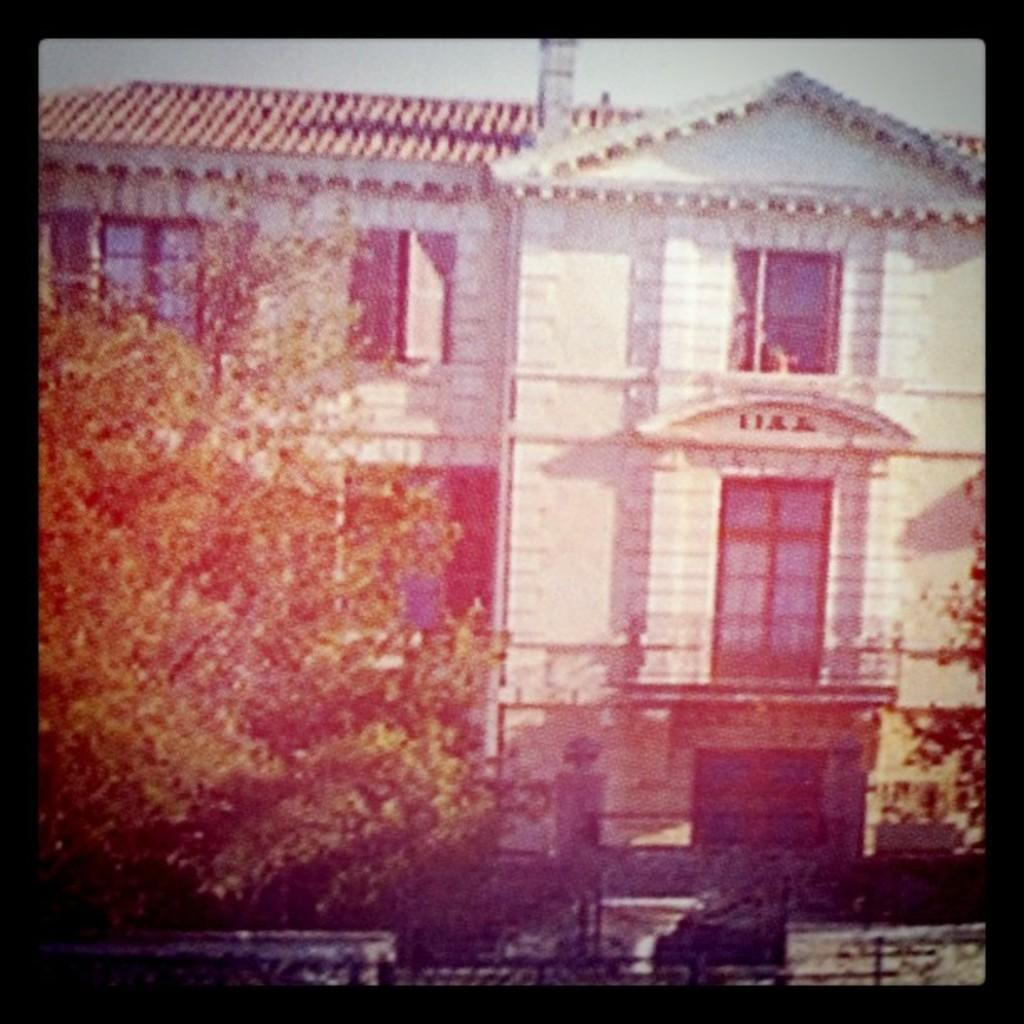What type of natural elements can be seen in the image? There are trees in the image. What type of structure is present in the image? There is a building with windows in the image. Can you describe any other objects in the image? There are some objects in the image. What can be seen in the background of the image? The sky is visible in the background of the image. What year is the secretary mentioned in the image? There is no mention of a secretary or a specific year in the image. 